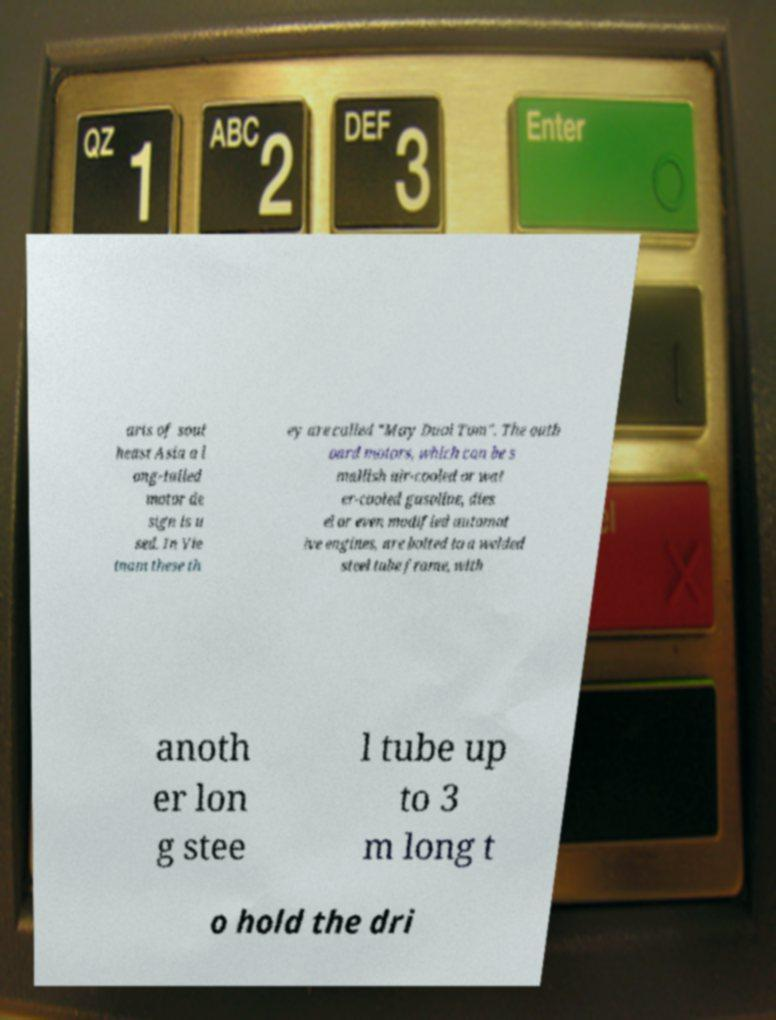There's text embedded in this image that I need extracted. Can you transcribe it verbatim? arts of sout heast Asia a l ong-tailed motor de sign is u sed. In Vie tnam these th ey are called "May Duoi Tom". The outb oard motors, which can be s mallish air-cooled or wat er-cooled gasoline, dies el or even modified automot ive engines, are bolted to a welded steel tube frame, with anoth er lon g stee l tube up to 3 m long t o hold the dri 